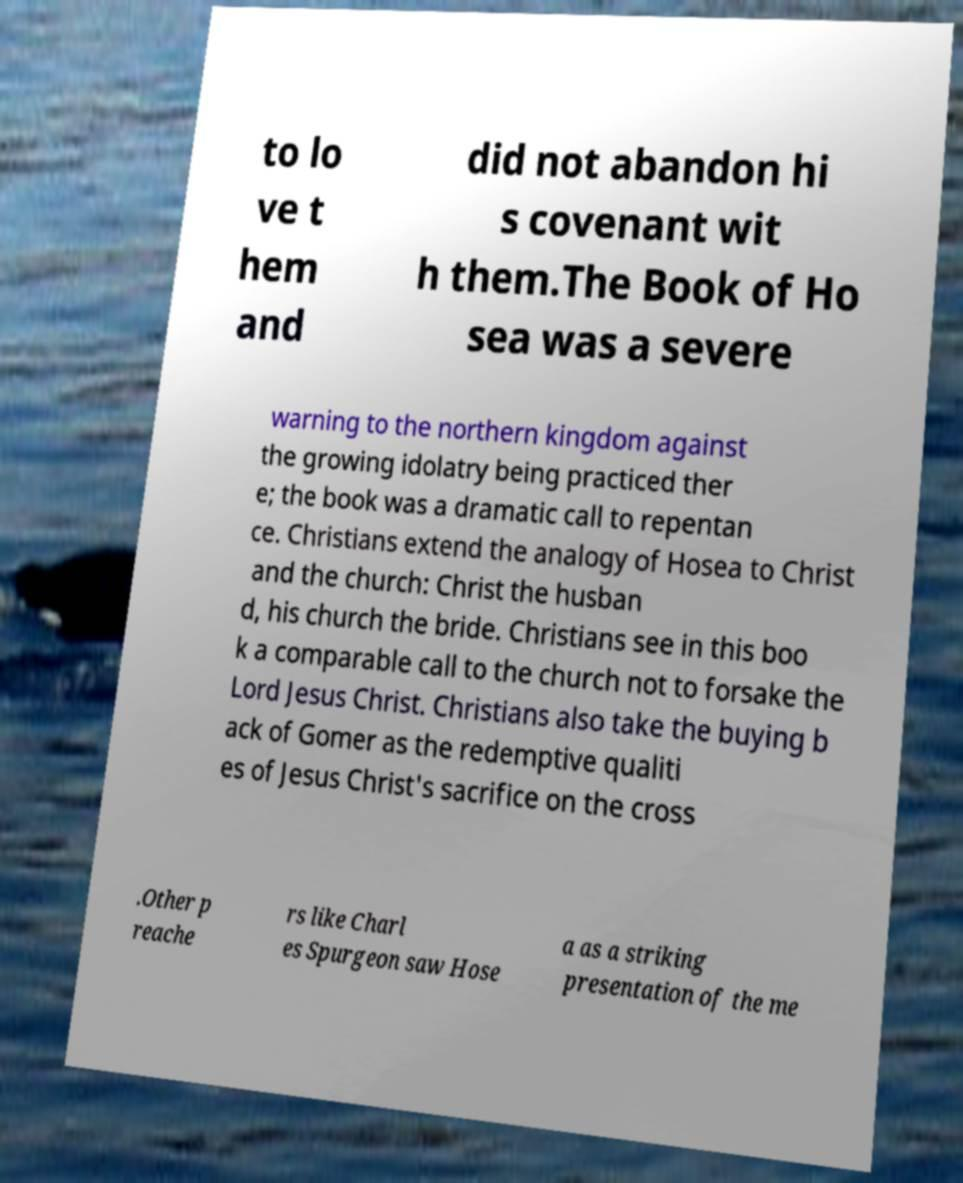Can you accurately transcribe the text from the provided image for me? to lo ve t hem and did not abandon hi s covenant wit h them.The Book of Ho sea was a severe warning to the northern kingdom against the growing idolatry being practiced ther e; the book was a dramatic call to repentan ce. Christians extend the analogy of Hosea to Christ and the church: Christ the husban d, his church the bride. Christians see in this boo k a comparable call to the church not to forsake the Lord Jesus Christ. Christians also take the buying b ack of Gomer as the redemptive qualiti es of Jesus Christ's sacrifice on the cross .Other p reache rs like Charl es Spurgeon saw Hose a as a striking presentation of the me 